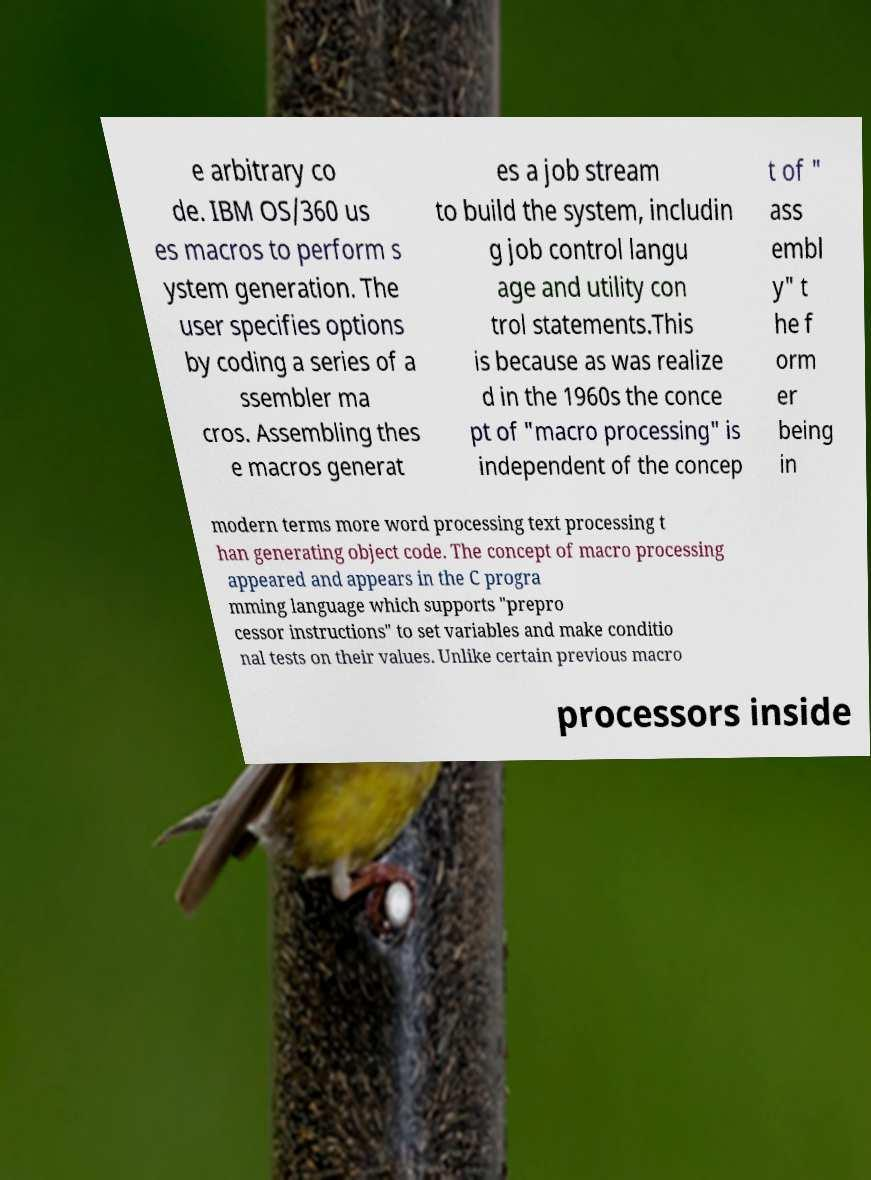I need the written content from this picture converted into text. Can you do that? e arbitrary co de. IBM OS/360 us es macros to perform s ystem generation. The user specifies options by coding a series of a ssembler ma cros. Assembling thes e macros generat es a job stream to build the system, includin g job control langu age and utility con trol statements.This is because as was realize d in the 1960s the conce pt of "macro processing" is independent of the concep t of " ass embl y" t he f orm er being in modern terms more word processing text processing t han generating object code. The concept of macro processing appeared and appears in the C progra mming language which supports "prepro cessor instructions" to set variables and make conditio nal tests on their values. Unlike certain previous macro processors inside 